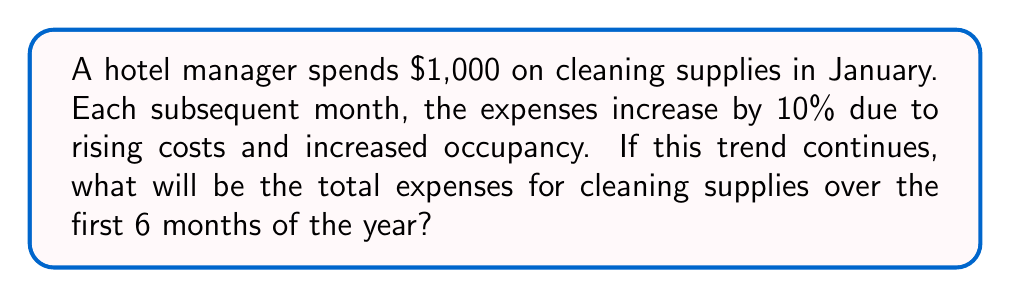Give your solution to this math problem. Let's approach this step-by-step:

1) We're dealing with a geometric sequence where each term is 1.1 times the previous term (10% increase = 1.1 multiplier).

2) The first term, $a_1 = 1000$.

3) The common ratio, $r = 1.1$.

4) We need to find the sum of the first 6 terms of this geometric sequence.

5) The formula for the sum of a geometric sequence is:

   $$S_n = \frac{a_1(1-r^n)}{1-r}$$

   Where $S_n$ is the sum of $n$ terms, $a_1$ is the first term, and $r$ is the common ratio.

6) Plugging in our values:

   $$S_6 = \frac{1000(1-1.1^6)}{1-1.1}$$

7) Simplify:
   $$S_6 = \frac{1000(1-1.771561)}{-0.1}$$
   $$S_6 = \frac{1000(-0.771561)}{-0.1}$$
   $$S_6 = 7715.61$$

8) Rounding to the nearest dollar: $7,716

Therefore, the total expenses for cleaning supplies over the first 6 months will be $7,716.
Answer: $7,716 